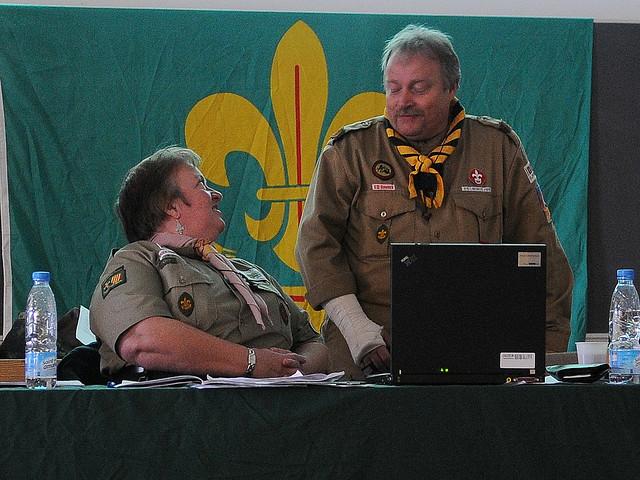What event are they holding here?
Quick response, please. Boy scouts. What organization are these men part of?
Write a very short answer. Boy scouts. What symbol is in the background?
Short answer required. Fleur de lis. 